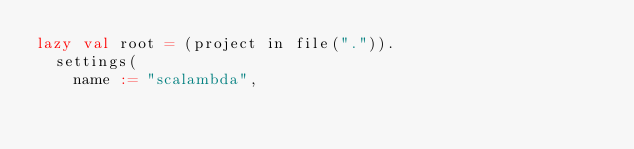Convert code to text. <code><loc_0><loc_0><loc_500><loc_500><_Scala_>lazy val root = (project in file(".")).
  settings(
    name := "scalambda",</code> 